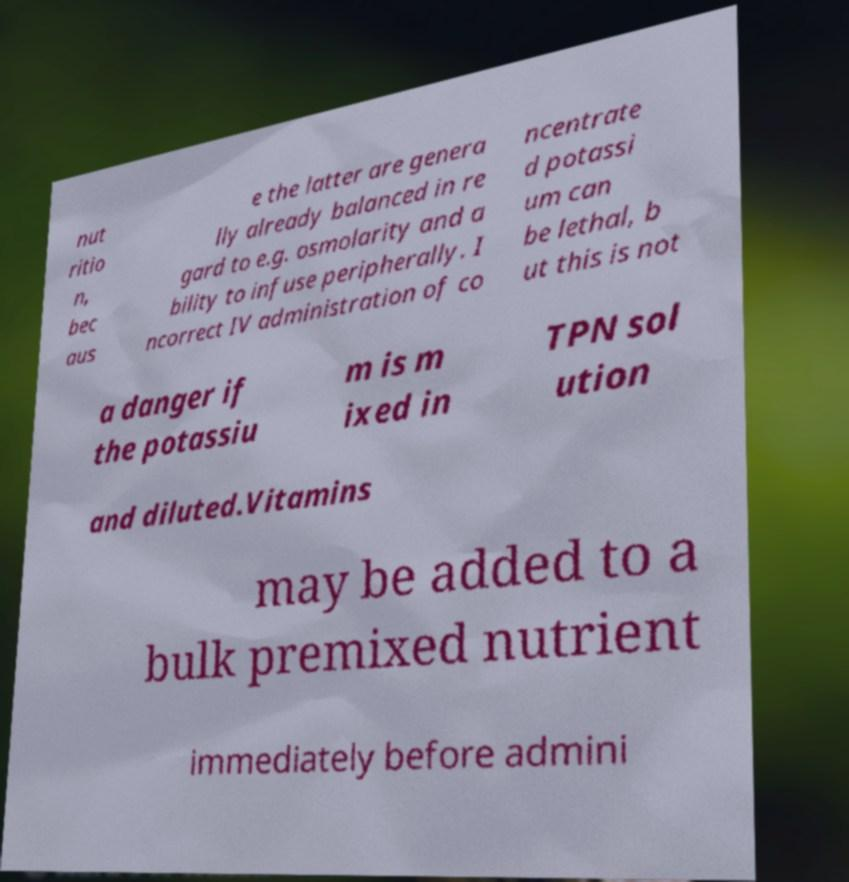What messages or text are displayed in this image? I need them in a readable, typed format. nut ritio n, bec aus e the latter are genera lly already balanced in re gard to e.g. osmolarity and a bility to infuse peripherally. I ncorrect IV administration of co ncentrate d potassi um can be lethal, b ut this is not a danger if the potassiu m is m ixed in TPN sol ution and diluted.Vitamins may be added to a bulk premixed nutrient immediately before admini 